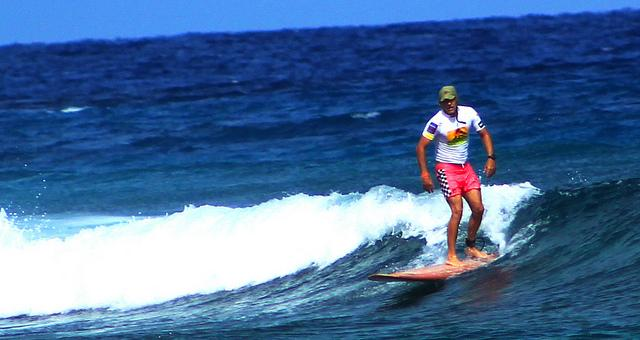What might he have applied before going out there?

Choices:
A) hairspray
B) lipstick
C) sunscreen
D) foundation sunscreen 